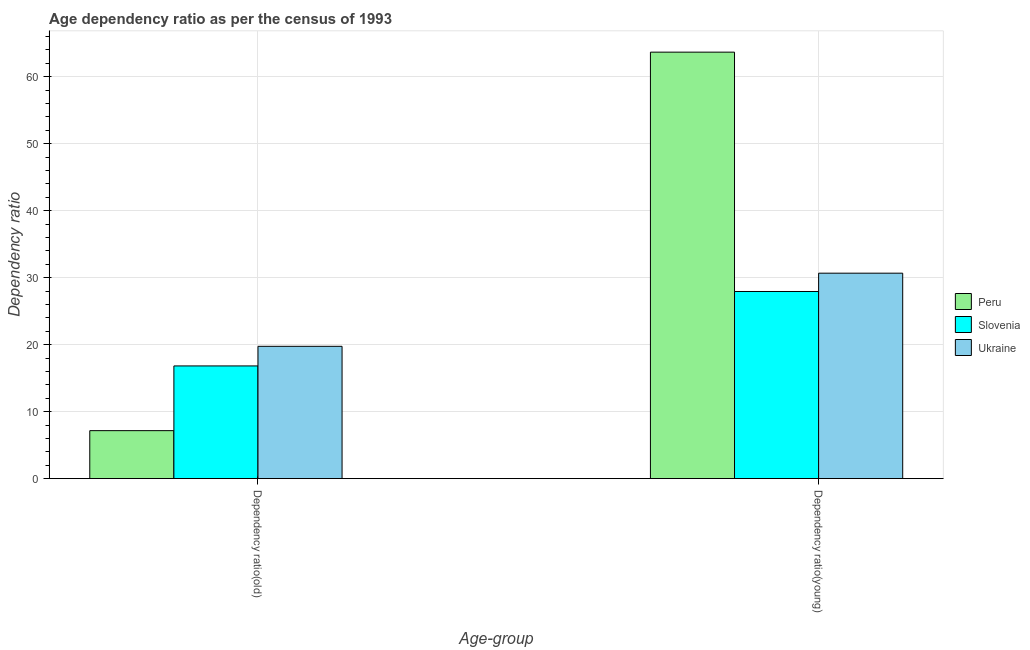How many bars are there on the 1st tick from the right?
Provide a succinct answer. 3. What is the label of the 2nd group of bars from the left?
Offer a very short reply. Dependency ratio(young). What is the age dependency ratio(young) in Ukraine?
Your answer should be very brief. 30.67. Across all countries, what is the maximum age dependency ratio(young)?
Your answer should be very brief. 63.68. Across all countries, what is the minimum age dependency ratio(young)?
Provide a short and direct response. 27.94. In which country was the age dependency ratio(old) maximum?
Make the answer very short. Ukraine. What is the total age dependency ratio(old) in the graph?
Your answer should be compact. 43.74. What is the difference between the age dependency ratio(young) in Slovenia and that in Peru?
Offer a very short reply. -35.74. What is the difference between the age dependency ratio(young) in Slovenia and the age dependency ratio(old) in Ukraine?
Your response must be concise. 8.19. What is the average age dependency ratio(old) per country?
Provide a short and direct response. 14.58. What is the difference between the age dependency ratio(young) and age dependency ratio(old) in Slovenia?
Provide a succinct answer. 11.12. What is the ratio of the age dependency ratio(old) in Peru to that in Ukraine?
Your answer should be very brief. 0.36. Is the age dependency ratio(young) in Peru less than that in Slovenia?
Provide a short and direct response. No. In how many countries, is the age dependency ratio(old) greater than the average age dependency ratio(old) taken over all countries?
Your answer should be compact. 2. What does the 2nd bar from the right in Dependency ratio(young) represents?
Provide a short and direct response. Slovenia. How many bars are there?
Offer a terse response. 6. Are all the bars in the graph horizontal?
Ensure brevity in your answer.  No. How many countries are there in the graph?
Provide a short and direct response. 3. What is the difference between two consecutive major ticks on the Y-axis?
Your answer should be very brief. 10. Does the graph contain any zero values?
Offer a very short reply. No. Where does the legend appear in the graph?
Provide a succinct answer. Center right. How many legend labels are there?
Keep it short and to the point. 3. How are the legend labels stacked?
Keep it short and to the point. Vertical. What is the title of the graph?
Provide a succinct answer. Age dependency ratio as per the census of 1993. What is the label or title of the X-axis?
Provide a short and direct response. Age-group. What is the label or title of the Y-axis?
Give a very brief answer. Dependency ratio. What is the Dependency ratio of Peru in Dependency ratio(old)?
Ensure brevity in your answer.  7.16. What is the Dependency ratio in Slovenia in Dependency ratio(old)?
Your answer should be very brief. 16.83. What is the Dependency ratio of Ukraine in Dependency ratio(old)?
Offer a very short reply. 19.75. What is the Dependency ratio of Peru in Dependency ratio(young)?
Make the answer very short. 63.68. What is the Dependency ratio in Slovenia in Dependency ratio(young)?
Your response must be concise. 27.94. What is the Dependency ratio of Ukraine in Dependency ratio(young)?
Keep it short and to the point. 30.67. Across all Age-group, what is the maximum Dependency ratio of Peru?
Your answer should be compact. 63.68. Across all Age-group, what is the maximum Dependency ratio of Slovenia?
Your answer should be very brief. 27.94. Across all Age-group, what is the maximum Dependency ratio in Ukraine?
Keep it short and to the point. 30.67. Across all Age-group, what is the minimum Dependency ratio in Peru?
Your response must be concise. 7.16. Across all Age-group, what is the minimum Dependency ratio of Slovenia?
Make the answer very short. 16.83. Across all Age-group, what is the minimum Dependency ratio of Ukraine?
Provide a succinct answer. 19.75. What is the total Dependency ratio in Peru in the graph?
Give a very brief answer. 70.84. What is the total Dependency ratio in Slovenia in the graph?
Keep it short and to the point. 44.77. What is the total Dependency ratio in Ukraine in the graph?
Offer a very short reply. 50.43. What is the difference between the Dependency ratio in Peru in Dependency ratio(old) and that in Dependency ratio(young)?
Your response must be concise. -56.52. What is the difference between the Dependency ratio in Slovenia in Dependency ratio(old) and that in Dependency ratio(young)?
Make the answer very short. -11.12. What is the difference between the Dependency ratio in Ukraine in Dependency ratio(old) and that in Dependency ratio(young)?
Provide a short and direct response. -10.92. What is the difference between the Dependency ratio in Peru in Dependency ratio(old) and the Dependency ratio in Slovenia in Dependency ratio(young)?
Make the answer very short. -20.78. What is the difference between the Dependency ratio of Peru in Dependency ratio(old) and the Dependency ratio of Ukraine in Dependency ratio(young)?
Give a very brief answer. -23.51. What is the difference between the Dependency ratio of Slovenia in Dependency ratio(old) and the Dependency ratio of Ukraine in Dependency ratio(young)?
Provide a short and direct response. -13.85. What is the average Dependency ratio in Peru per Age-group?
Offer a terse response. 35.42. What is the average Dependency ratio of Slovenia per Age-group?
Your answer should be compact. 22.38. What is the average Dependency ratio in Ukraine per Age-group?
Your response must be concise. 25.21. What is the difference between the Dependency ratio in Peru and Dependency ratio in Slovenia in Dependency ratio(old)?
Provide a succinct answer. -9.66. What is the difference between the Dependency ratio of Peru and Dependency ratio of Ukraine in Dependency ratio(old)?
Your answer should be very brief. -12.59. What is the difference between the Dependency ratio in Slovenia and Dependency ratio in Ukraine in Dependency ratio(old)?
Offer a terse response. -2.93. What is the difference between the Dependency ratio in Peru and Dependency ratio in Slovenia in Dependency ratio(young)?
Make the answer very short. 35.74. What is the difference between the Dependency ratio in Peru and Dependency ratio in Ukraine in Dependency ratio(young)?
Offer a terse response. 33. What is the difference between the Dependency ratio in Slovenia and Dependency ratio in Ukraine in Dependency ratio(young)?
Keep it short and to the point. -2.73. What is the ratio of the Dependency ratio of Peru in Dependency ratio(old) to that in Dependency ratio(young)?
Provide a succinct answer. 0.11. What is the ratio of the Dependency ratio in Slovenia in Dependency ratio(old) to that in Dependency ratio(young)?
Your answer should be compact. 0.6. What is the ratio of the Dependency ratio in Ukraine in Dependency ratio(old) to that in Dependency ratio(young)?
Give a very brief answer. 0.64. What is the difference between the highest and the second highest Dependency ratio of Peru?
Keep it short and to the point. 56.52. What is the difference between the highest and the second highest Dependency ratio in Slovenia?
Your answer should be compact. 11.12. What is the difference between the highest and the second highest Dependency ratio in Ukraine?
Provide a succinct answer. 10.92. What is the difference between the highest and the lowest Dependency ratio in Peru?
Your answer should be compact. 56.52. What is the difference between the highest and the lowest Dependency ratio in Slovenia?
Provide a succinct answer. 11.12. What is the difference between the highest and the lowest Dependency ratio of Ukraine?
Provide a succinct answer. 10.92. 